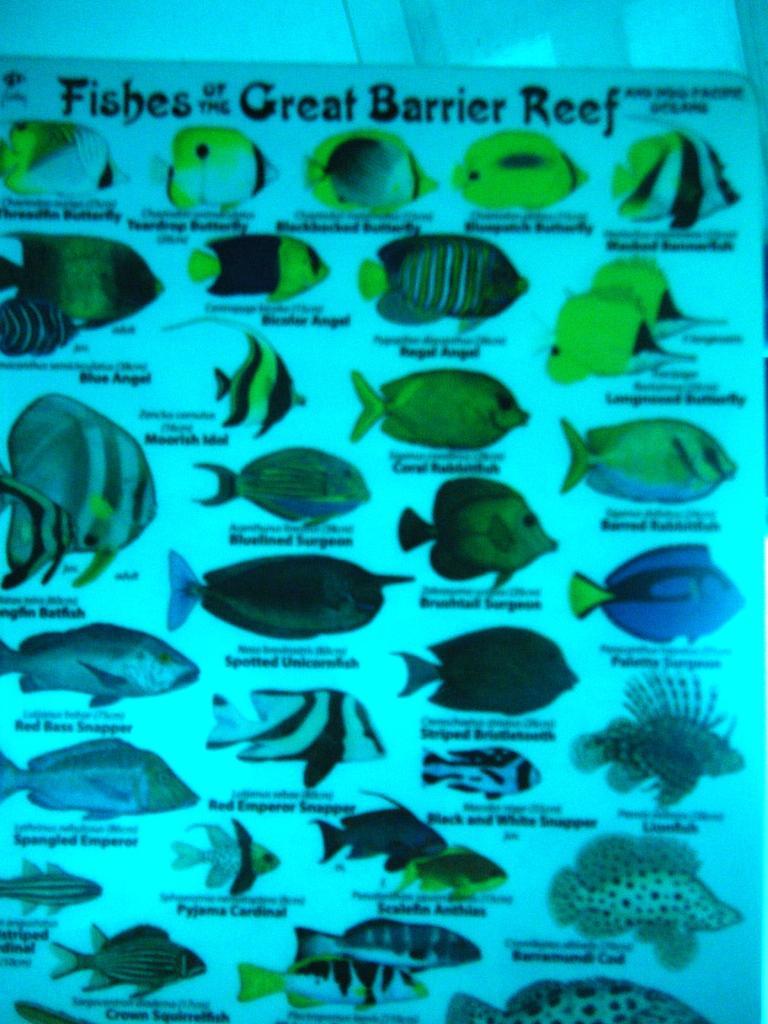Could you give a brief overview of what you see in this image? In this image there is a fishes chart in the middle. In the chart there are so many different kind of fishes with their names. 